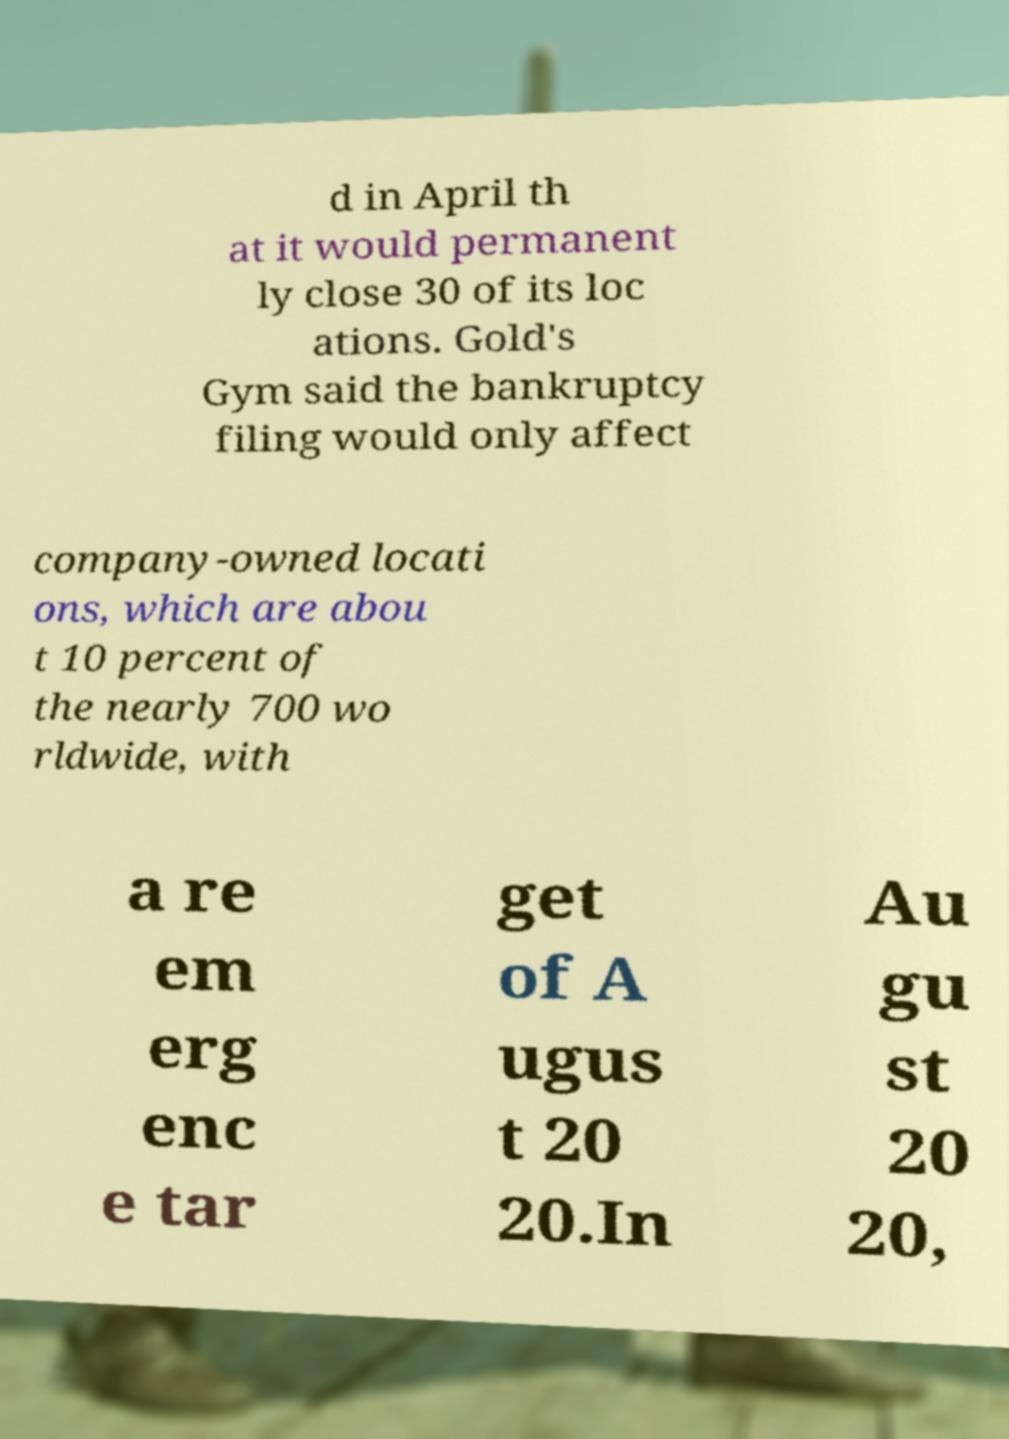For documentation purposes, I need the text within this image transcribed. Could you provide that? d in April th at it would permanent ly close 30 of its loc ations. Gold's Gym said the bankruptcy filing would only affect company-owned locati ons, which are abou t 10 percent of the nearly 700 wo rldwide, with a re em erg enc e tar get of A ugus t 20 20.In Au gu st 20 20, 